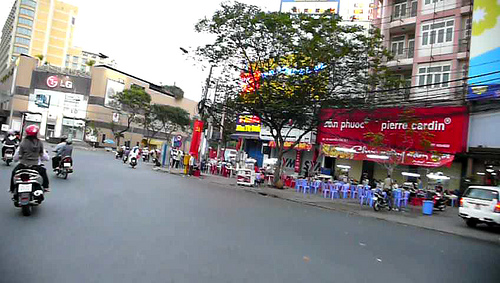On which side of the image are the bikes? The bikes are primarily on the left side of the image. 